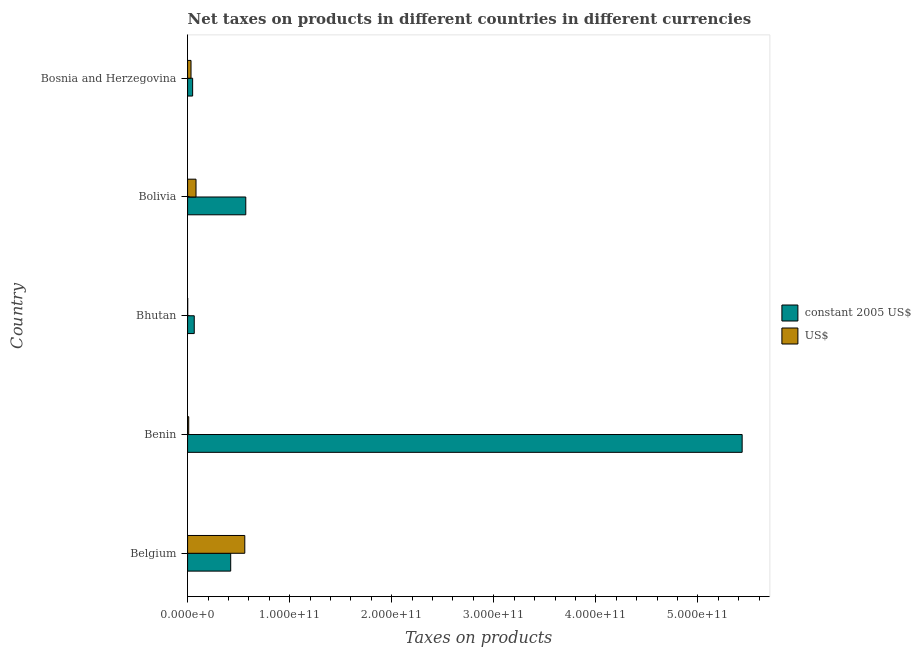How many groups of bars are there?
Ensure brevity in your answer.  5. Are the number of bars per tick equal to the number of legend labels?
Give a very brief answer. Yes. How many bars are there on the 1st tick from the bottom?
Your answer should be compact. 2. What is the label of the 3rd group of bars from the top?
Provide a succinct answer. Bhutan. What is the net taxes in us$ in Bosnia and Herzegovina?
Your response must be concise. 3.36e+09. Across all countries, what is the maximum net taxes in constant 2005 us$?
Your answer should be compact. 5.43e+11. Across all countries, what is the minimum net taxes in us$?
Offer a very short reply. 1.07e+08. In which country was the net taxes in constant 2005 us$ maximum?
Give a very brief answer. Benin. In which country was the net taxes in constant 2005 us$ minimum?
Ensure brevity in your answer.  Bosnia and Herzegovina. What is the total net taxes in constant 2005 us$ in the graph?
Provide a short and direct response. 6.54e+11. What is the difference between the net taxes in us$ in Bolivia and that in Bosnia and Herzegovina?
Your response must be concise. 4.89e+09. What is the difference between the net taxes in us$ in Bhutan and the net taxes in constant 2005 us$ in Belgium?
Offer a terse response. -4.21e+1. What is the average net taxes in constant 2005 us$ per country?
Ensure brevity in your answer.  1.31e+11. What is the difference between the net taxes in us$ and net taxes in constant 2005 us$ in Benin?
Your answer should be compact. -5.42e+11. What is the ratio of the net taxes in constant 2005 us$ in Belgium to that in Bosnia and Herzegovina?
Give a very brief answer. 8.54. Is the net taxes in us$ in Belgium less than that in Bosnia and Herzegovina?
Provide a short and direct response. No. What is the difference between the highest and the second highest net taxes in us$?
Your response must be concise. 4.78e+1. What is the difference between the highest and the lowest net taxes in us$?
Your answer should be very brief. 5.59e+1. In how many countries, is the net taxes in us$ greater than the average net taxes in us$ taken over all countries?
Make the answer very short. 1. What does the 2nd bar from the top in Bosnia and Herzegovina represents?
Ensure brevity in your answer.  Constant 2005 us$. What does the 1st bar from the bottom in Benin represents?
Your answer should be very brief. Constant 2005 us$. How many countries are there in the graph?
Give a very brief answer. 5. What is the difference between two consecutive major ticks on the X-axis?
Your answer should be very brief. 1.00e+11. How are the legend labels stacked?
Your response must be concise. Vertical. What is the title of the graph?
Offer a terse response. Net taxes on products in different countries in different currencies. Does "Male labourers" appear as one of the legend labels in the graph?
Make the answer very short. No. What is the label or title of the X-axis?
Give a very brief answer. Taxes on products. What is the label or title of the Y-axis?
Keep it short and to the point. Country. What is the Taxes on products in constant 2005 US$ in Belgium?
Offer a very short reply. 4.22e+1. What is the Taxes on products of US$ in Belgium?
Provide a succinct answer. 5.60e+1. What is the Taxes on products in constant 2005 US$ in Benin?
Offer a very short reply. 5.43e+11. What is the Taxes on products of US$ in Benin?
Make the answer very short. 1.10e+09. What is the Taxes on products of constant 2005 US$ in Bhutan?
Provide a short and direct response. 6.52e+09. What is the Taxes on products of US$ in Bhutan?
Your answer should be compact. 1.07e+08. What is the Taxes on products in constant 2005 US$ in Bolivia?
Give a very brief answer. 5.70e+1. What is the Taxes on products in US$ in Bolivia?
Provide a succinct answer. 8.25e+09. What is the Taxes on products in constant 2005 US$ in Bosnia and Herzegovina?
Your answer should be very brief. 4.95e+09. What is the Taxes on products in US$ in Bosnia and Herzegovina?
Ensure brevity in your answer.  3.36e+09. Across all countries, what is the maximum Taxes on products of constant 2005 US$?
Your response must be concise. 5.43e+11. Across all countries, what is the maximum Taxes on products in US$?
Ensure brevity in your answer.  5.60e+1. Across all countries, what is the minimum Taxes on products of constant 2005 US$?
Keep it short and to the point. 4.95e+09. Across all countries, what is the minimum Taxes on products of US$?
Your answer should be compact. 1.07e+08. What is the total Taxes on products of constant 2005 US$ in the graph?
Offer a terse response. 6.54e+11. What is the total Taxes on products in US$ in the graph?
Give a very brief answer. 6.88e+1. What is the difference between the Taxes on products of constant 2005 US$ in Belgium and that in Benin?
Your answer should be very brief. -5.01e+11. What is the difference between the Taxes on products in US$ in Belgium and that in Benin?
Your answer should be very brief. 5.49e+1. What is the difference between the Taxes on products of constant 2005 US$ in Belgium and that in Bhutan?
Make the answer very short. 3.57e+1. What is the difference between the Taxes on products in US$ in Belgium and that in Bhutan?
Your answer should be compact. 5.59e+1. What is the difference between the Taxes on products of constant 2005 US$ in Belgium and that in Bolivia?
Give a very brief answer. -1.48e+1. What is the difference between the Taxes on products of US$ in Belgium and that in Bolivia?
Keep it short and to the point. 4.78e+1. What is the difference between the Taxes on products of constant 2005 US$ in Belgium and that in Bosnia and Herzegovina?
Offer a terse response. 3.73e+1. What is the difference between the Taxes on products of US$ in Belgium and that in Bosnia and Herzegovina?
Offer a terse response. 5.27e+1. What is the difference between the Taxes on products of constant 2005 US$ in Benin and that in Bhutan?
Give a very brief answer. 5.37e+11. What is the difference between the Taxes on products of US$ in Benin and that in Bhutan?
Provide a succinct answer. 9.92e+08. What is the difference between the Taxes on products of constant 2005 US$ in Benin and that in Bolivia?
Ensure brevity in your answer.  4.86e+11. What is the difference between the Taxes on products of US$ in Benin and that in Bolivia?
Make the answer very short. -7.15e+09. What is the difference between the Taxes on products in constant 2005 US$ in Benin and that in Bosnia and Herzegovina?
Make the answer very short. 5.38e+11. What is the difference between the Taxes on products of US$ in Benin and that in Bosnia and Herzegovina?
Offer a terse response. -2.26e+09. What is the difference between the Taxes on products in constant 2005 US$ in Bhutan and that in Bolivia?
Your answer should be very brief. -5.05e+1. What is the difference between the Taxes on products of US$ in Bhutan and that in Bolivia?
Offer a very short reply. -8.14e+09. What is the difference between the Taxes on products of constant 2005 US$ in Bhutan and that in Bosnia and Herzegovina?
Offer a terse response. 1.57e+09. What is the difference between the Taxes on products of US$ in Bhutan and that in Bosnia and Herzegovina?
Provide a succinct answer. -3.25e+09. What is the difference between the Taxes on products of constant 2005 US$ in Bolivia and that in Bosnia and Herzegovina?
Your response must be concise. 5.21e+1. What is the difference between the Taxes on products in US$ in Bolivia and that in Bosnia and Herzegovina?
Offer a terse response. 4.89e+09. What is the difference between the Taxes on products of constant 2005 US$ in Belgium and the Taxes on products of US$ in Benin?
Keep it short and to the point. 4.11e+1. What is the difference between the Taxes on products of constant 2005 US$ in Belgium and the Taxes on products of US$ in Bhutan?
Your answer should be compact. 4.21e+1. What is the difference between the Taxes on products in constant 2005 US$ in Belgium and the Taxes on products in US$ in Bolivia?
Make the answer very short. 3.40e+1. What is the difference between the Taxes on products in constant 2005 US$ in Belgium and the Taxes on products in US$ in Bosnia and Herzegovina?
Ensure brevity in your answer.  3.89e+1. What is the difference between the Taxes on products of constant 2005 US$ in Benin and the Taxes on products of US$ in Bhutan?
Make the answer very short. 5.43e+11. What is the difference between the Taxes on products in constant 2005 US$ in Benin and the Taxes on products in US$ in Bolivia?
Provide a succinct answer. 5.35e+11. What is the difference between the Taxes on products of constant 2005 US$ in Benin and the Taxes on products of US$ in Bosnia and Herzegovina?
Keep it short and to the point. 5.40e+11. What is the difference between the Taxes on products of constant 2005 US$ in Bhutan and the Taxes on products of US$ in Bolivia?
Keep it short and to the point. -1.73e+09. What is the difference between the Taxes on products in constant 2005 US$ in Bhutan and the Taxes on products in US$ in Bosnia and Herzegovina?
Your answer should be very brief. 3.16e+09. What is the difference between the Taxes on products of constant 2005 US$ in Bolivia and the Taxes on products of US$ in Bosnia and Herzegovina?
Give a very brief answer. 5.36e+1. What is the average Taxes on products of constant 2005 US$ per country?
Make the answer very short. 1.31e+11. What is the average Taxes on products of US$ per country?
Your answer should be compact. 1.38e+1. What is the difference between the Taxes on products of constant 2005 US$ and Taxes on products of US$ in Belgium?
Keep it short and to the point. -1.38e+1. What is the difference between the Taxes on products of constant 2005 US$ and Taxes on products of US$ in Benin?
Give a very brief answer. 5.42e+11. What is the difference between the Taxes on products in constant 2005 US$ and Taxes on products in US$ in Bhutan?
Provide a short and direct response. 6.41e+09. What is the difference between the Taxes on products in constant 2005 US$ and Taxes on products in US$ in Bolivia?
Provide a short and direct response. 4.87e+1. What is the difference between the Taxes on products of constant 2005 US$ and Taxes on products of US$ in Bosnia and Herzegovina?
Make the answer very short. 1.59e+09. What is the ratio of the Taxes on products of constant 2005 US$ in Belgium to that in Benin?
Provide a succinct answer. 0.08. What is the ratio of the Taxes on products in US$ in Belgium to that in Benin?
Ensure brevity in your answer.  50.99. What is the ratio of the Taxes on products of constant 2005 US$ in Belgium to that in Bhutan?
Keep it short and to the point. 6.48. What is the ratio of the Taxes on products in US$ in Belgium to that in Bhutan?
Your response must be concise. 524.86. What is the ratio of the Taxes on products of constant 2005 US$ in Belgium to that in Bolivia?
Offer a very short reply. 0.74. What is the ratio of the Taxes on products in US$ in Belgium to that in Bolivia?
Keep it short and to the point. 6.79. What is the ratio of the Taxes on products of constant 2005 US$ in Belgium to that in Bosnia and Herzegovina?
Give a very brief answer. 8.54. What is the ratio of the Taxes on products in US$ in Belgium to that in Bosnia and Herzegovina?
Keep it short and to the point. 16.7. What is the ratio of the Taxes on products of constant 2005 US$ in Benin to that in Bhutan?
Provide a succinct answer. 83.38. What is the ratio of the Taxes on products of US$ in Benin to that in Bhutan?
Provide a succinct answer. 10.29. What is the ratio of the Taxes on products of constant 2005 US$ in Benin to that in Bolivia?
Your answer should be very brief. 9.53. What is the ratio of the Taxes on products in US$ in Benin to that in Bolivia?
Provide a short and direct response. 0.13. What is the ratio of the Taxes on products in constant 2005 US$ in Benin to that in Bosnia and Herzegovina?
Offer a terse response. 109.84. What is the ratio of the Taxes on products of US$ in Benin to that in Bosnia and Herzegovina?
Provide a short and direct response. 0.33. What is the ratio of the Taxes on products in constant 2005 US$ in Bhutan to that in Bolivia?
Ensure brevity in your answer.  0.11. What is the ratio of the Taxes on products in US$ in Bhutan to that in Bolivia?
Offer a terse response. 0.01. What is the ratio of the Taxes on products of constant 2005 US$ in Bhutan to that in Bosnia and Herzegovina?
Provide a short and direct response. 1.32. What is the ratio of the Taxes on products in US$ in Bhutan to that in Bosnia and Herzegovina?
Your response must be concise. 0.03. What is the ratio of the Taxes on products of constant 2005 US$ in Bolivia to that in Bosnia and Herzegovina?
Offer a very short reply. 11.52. What is the ratio of the Taxes on products in US$ in Bolivia to that in Bosnia and Herzegovina?
Offer a terse response. 2.46. What is the difference between the highest and the second highest Taxes on products of constant 2005 US$?
Your response must be concise. 4.86e+11. What is the difference between the highest and the second highest Taxes on products of US$?
Provide a short and direct response. 4.78e+1. What is the difference between the highest and the lowest Taxes on products in constant 2005 US$?
Offer a very short reply. 5.38e+11. What is the difference between the highest and the lowest Taxes on products in US$?
Keep it short and to the point. 5.59e+1. 